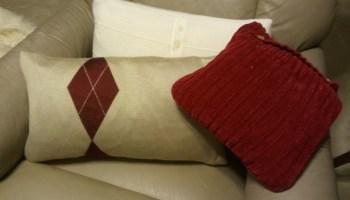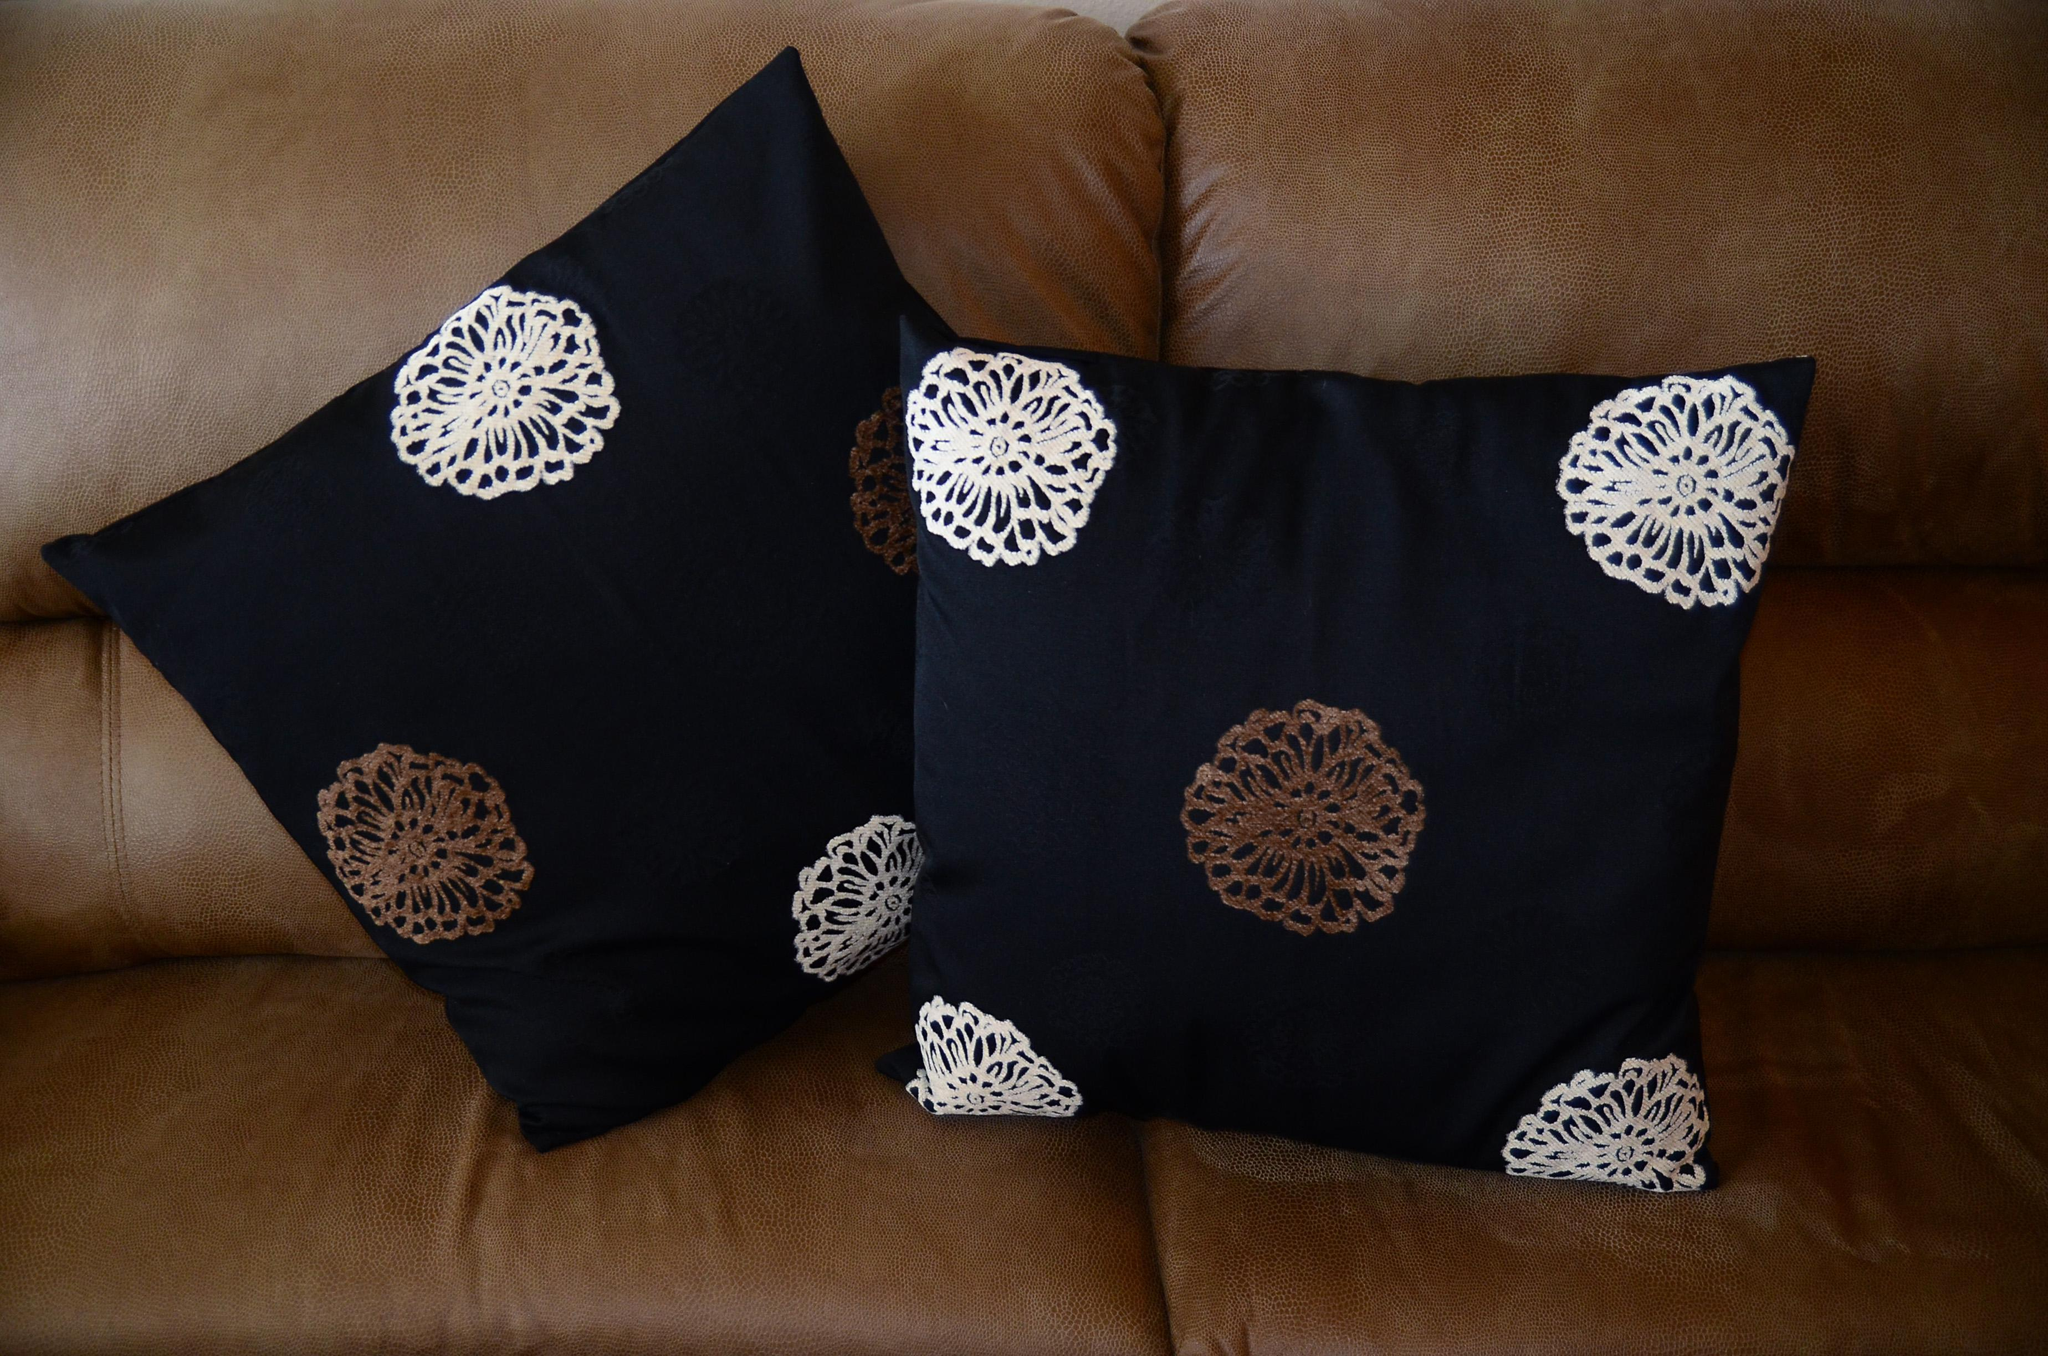The first image is the image on the left, the second image is the image on the right. Examine the images to the left and right. Is the description "The left image contains at least five pillows." accurate? Answer yes or no. No. The first image is the image on the left, the second image is the image on the right. Evaluate the accuracy of this statement regarding the images: "A brown sofa holds two pillows decorated with round doily shapes on a dark background.". Is it true? Answer yes or no. Yes. 